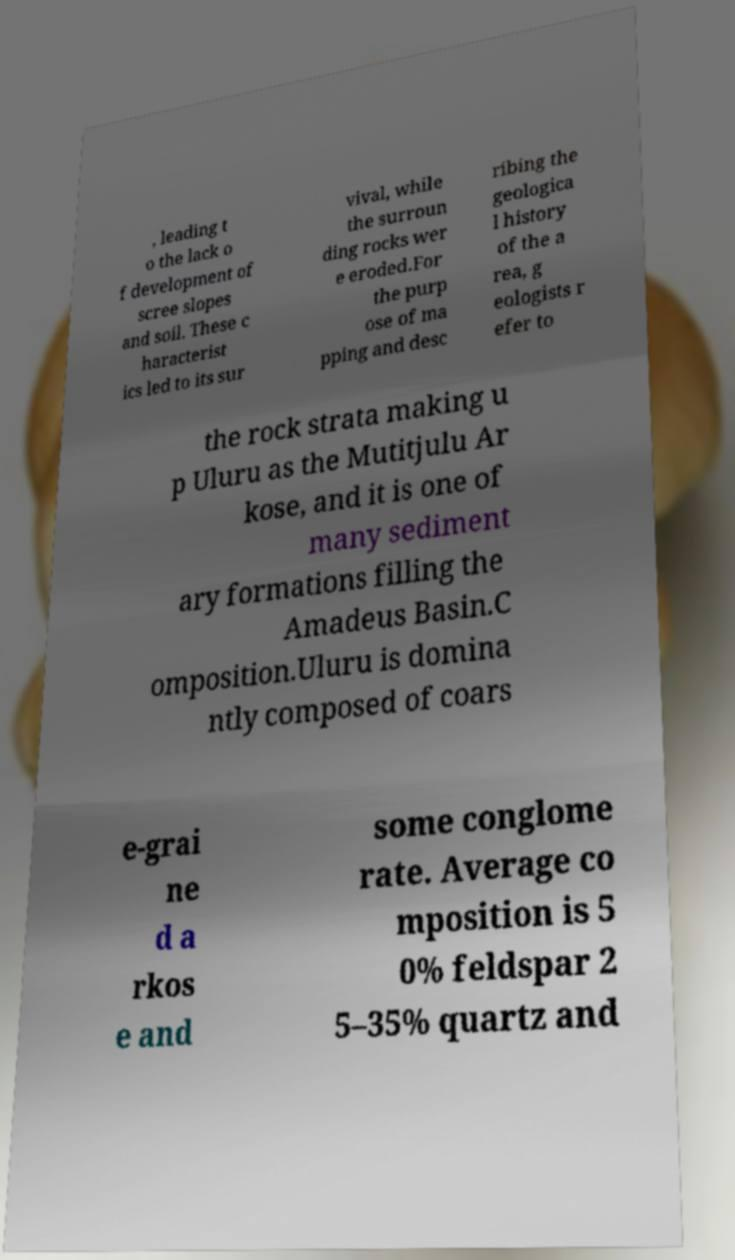I need the written content from this picture converted into text. Can you do that? , leading t o the lack o f development of scree slopes and soil. These c haracterist ics led to its sur vival, while the surroun ding rocks wer e eroded.For the purp ose of ma pping and desc ribing the geologica l history of the a rea, g eologists r efer to the rock strata making u p Uluru as the Mutitjulu Ar kose, and it is one of many sediment ary formations filling the Amadeus Basin.C omposition.Uluru is domina ntly composed of coars e-grai ne d a rkos e and some conglome rate. Average co mposition is 5 0% feldspar 2 5–35% quartz and 